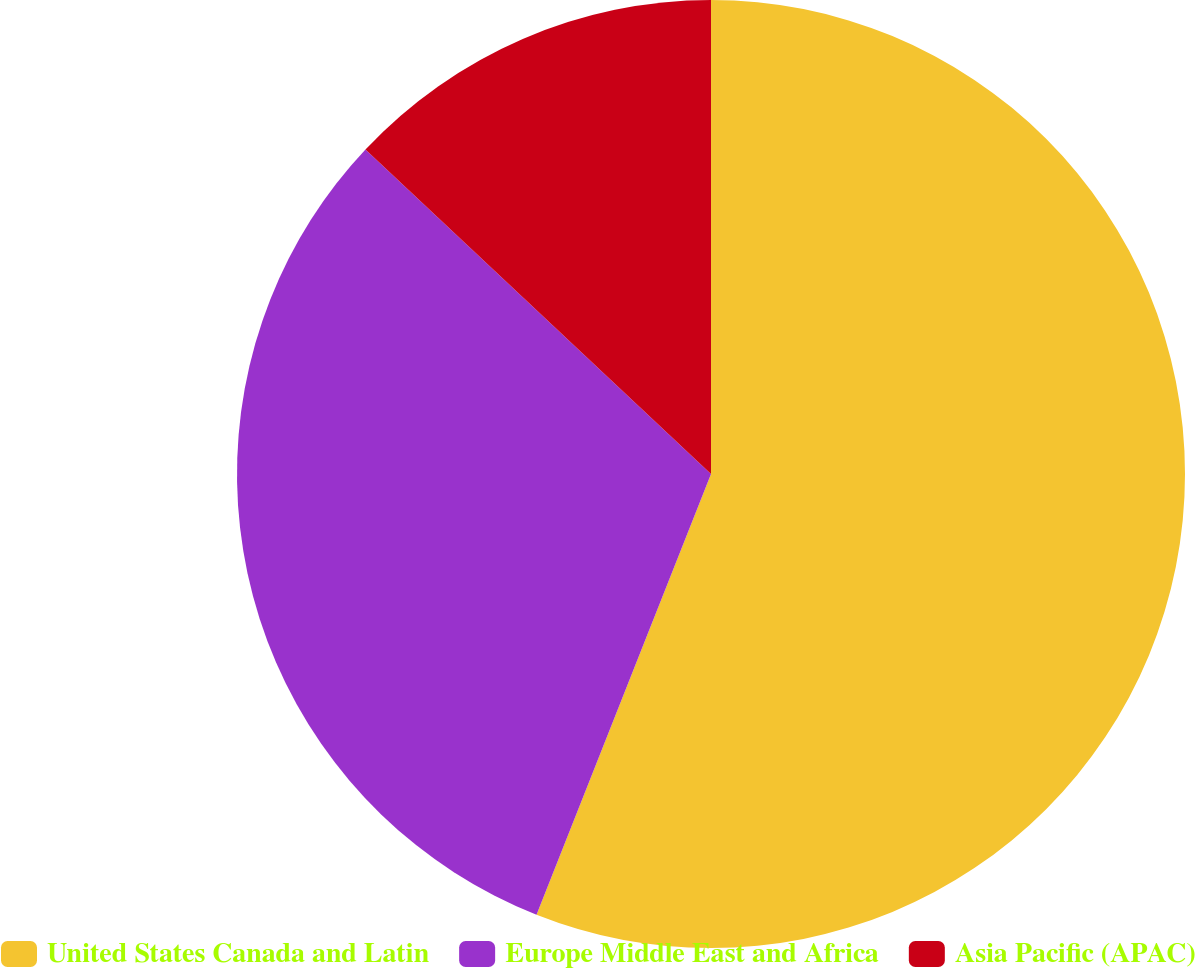Convert chart. <chart><loc_0><loc_0><loc_500><loc_500><pie_chart><fcel>United States Canada and Latin<fcel>Europe Middle East and Africa<fcel>Asia Pacific (APAC)<nl><fcel>56.0%<fcel>31.0%<fcel>13.0%<nl></chart> 